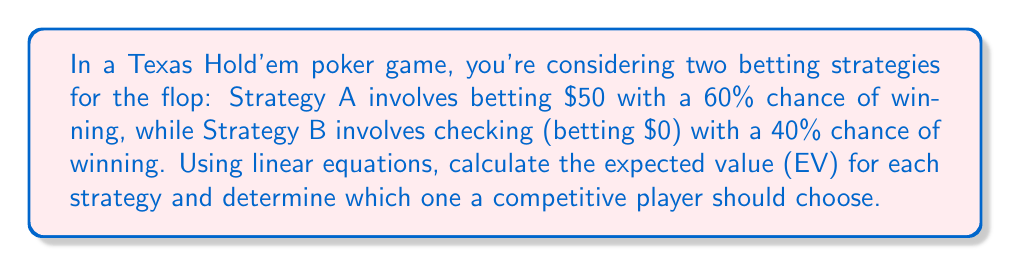Solve this math problem. Let's approach this step-by-step using linear equations:

1. Define variables:
   $x_A$ = Expected Value of Strategy A
   $x_B$ = Expected Value of Strategy B

2. Set up equations for each strategy:

   Strategy A:
   $$x_A = 0.6(50) + 0.4(-50)$$
   
   Strategy B:
   $$x_B = 0.4(0) + 0.6(0)$$

3. Solve for $x_A$:
   $$x_A = 30 - 20 = 10$$

4. Solve for $x_B$:
   $$x_B = 0 + 0 = 0$$

5. Compare the expected values:
   $x_A = 10$ > $x_B = 0$

The expected value of Strategy A ($10) is higher than Strategy B ($0).
Answer: Strategy A with EV = $10 